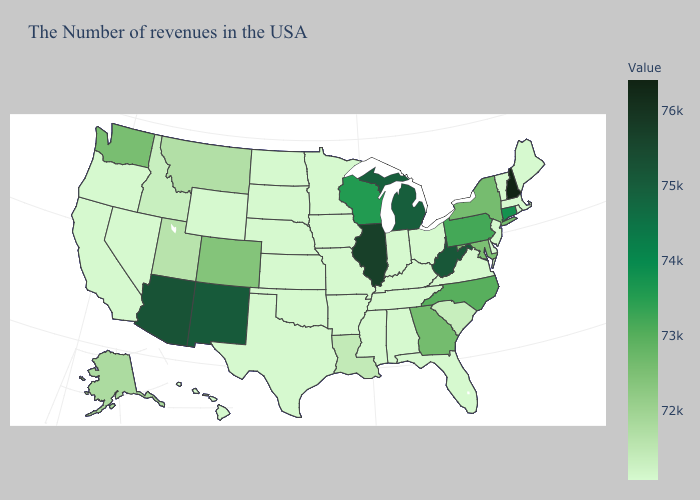Which states have the highest value in the USA?
Concise answer only. New Hampshire. Does South Carolina have the highest value in the USA?
Quick response, please. No. Which states have the lowest value in the MidWest?
Keep it brief. Ohio, Indiana, Missouri, Minnesota, Iowa, Kansas, Nebraska, South Dakota, North Dakota. Does Georgia have the lowest value in the USA?
Quick response, please. No. Does the map have missing data?
Quick response, please. No. Is the legend a continuous bar?
Quick response, please. Yes. Among the states that border Kentucky , does West Virginia have the lowest value?
Quick response, please. No. 